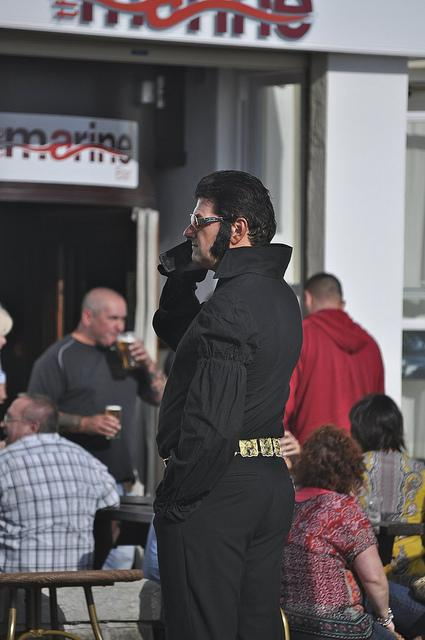The man in black is dressed like what star? elvis 